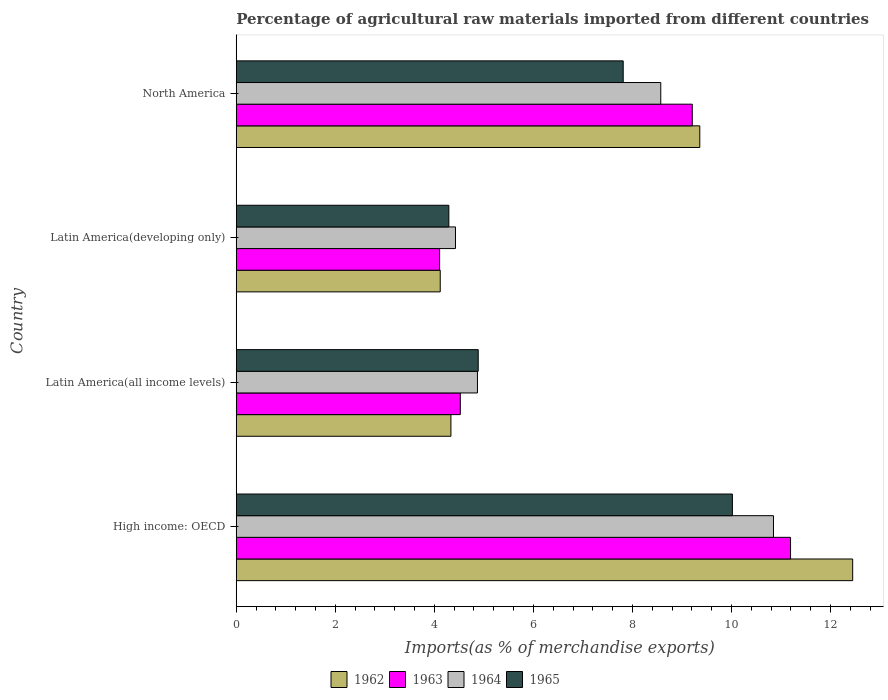How many groups of bars are there?
Your answer should be very brief. 4. Are the number of bars per tick equal to the number of legend labels?
Make the answer very short. Yes. Are the number of bars on each tick of the Y-axis equal?
Offer a terse response. Yes. How many bars are there on the 2nd tick from the top?
Provide a short and direct response. 4. How many bars are there on the 2nd tick from the bottom?
Your answer should be very brief. 4. What is the label of the 4th group of bars from the top?
Make the answer very short. High income: OECD. What is the percentage of imports to different countries in 1962 in High income: OECD?
Give a very brief answer. 12.45. Across all countries, what is the maximum percentage of imports to different countries in 1962?
Offer a very short reply. 12.45. Across all countries, what is the minimum percentage of imports to different countries in 1965?
Provide a succinct answer. 4.29. In which country was the percentage of imports to different countries in 1964 maximum?
Give a very brief answer. High income: OECD. In which country was the percentage of imports to different countries in 1963 minimum?
Offer a terse response. Latin America(developing only). What is the total percentage of imports to different countries in 1963 in the graph?
Keep it short and to the point. 29.03. What is the difference between the percentage of imports to different countries in 1962 in Latin America(developing only) and that in North America?
Your answer should be very brief. -5.24. What is the difference between the percentage of imports to different countries in 1964 in Latin America(all income levels) and the percentage of imports to different countries in 1965 in Latin America(developing only)?
Give a very brief answer. 0.58. What is the average percentage of imports to different countries in 1964 per country?
Your answer should be compact. 7.18. What is the difference between the percentage of imports to different countries in 1962 and percentage of imports to different countries in 1964 in Latin America(all income levels)?
Keep it short and to the point. -0.54. In how many countries, is the percentage of imports to different countries in 1964 greater than 7.6 %?
Offer a terse response. 2. What is the ratio of the percentage of imports to different countries in 1963 in Latin America(all income levels) to that in North America?
Give a very brief answer. 0.49. What is the difference between the highest and the second highest percentage of imports to different countries in 1964?
Your response must be concise. 2.28. What is the difference between the highest and the lowest percentage of imports to different countries in 1963?
Offer a very short reply. 7.09. In how many countries, is the percentage of imports to different countries in 1965 greater than the average percentage of imports to different countries in 1965 taken over all countries?
Make the answer very short. 2. Is the sum of the percentage of imports to different countries in 1963 in High income: OECD and Latin America(all income levels) greater than the maximum percentage of imports to different countries in 1964 across all countries?
Your response must be concise. Yes. Is it the case that in every country, the sum of the percentage of imports to different countries in 1963 and percentage of imports to different countries in 1965 is greater than the sum of percentage of imports to different countries in 1964 and percentage of imports to different countries in 1962?
Offer a terse response. No. What does the 1st bar from the top in High income: OECD represents?
Provide a succinct answer. 1965. What does the 3rd bar from the bottom in Latin America(all income levels) represents?
Your response must be concise. 1964. What is the difference between two consecutive major ticks on the X-axis?
Offer a very short reply. 2. Does the graph contain grids?
Offer a terse response. No. Where does the legend appear in the graph?
Offer a very short reply. Bottom center. How many legend labels are there?
Make the answer very short. 4. What is the title of the graph?
Your response must be concise. Percentage of agricultural raw materials imported from different countries. What is the label or title of the X-axis?
Give a very brief answer. Imports(as % of merchandise exports). What is the label or title of the Y-axis?
Provide a succinct answer. Country. What is the Imports(as % of merchandise exports) of 1962 in High income: OECD?
Ensure brevity in your answer.  12.45. What is the Imports(as % of merchandise exports) in 1963 in High income: OECD?
Your response must be concise. 11.19. What is the Imports(as % of merchandise exports) in 1964 in High income: OECD?
Your answer should be very brief. 10.85. What is the Imports(as % of merchandise exports) of 1965 in High income: OECD?
Your answer should be compact. 10.02. What is the Imports(as % of merchandise exports) of 1962 in Latin America(all income levels)?
Provide a succinct answer. 4.33. What is the Imports(as % of merchandise exports) of 1963 in Latin America(all income levels)?
Provide a short and direct response. 4.52. What is the Imports(as % of merchandise exports) of 1964 in Latin America(all income levels)?
Provide a short and direct response. 4.87. What is the Imports(as % of merchandise exports) of 1965 in Latin America(all income levels)?
Offer a very short reply. 4.89. What is the Imports(as % of merchandise exports) of 1962 in Latin America(developing only)?
Offer a very short reply. 4.12. What is the Imports(as % of merchandise exports) in 1963 in Latin America(developing only)?
Give a very brief answer. 4.11. What is the Imports(as % of merchandise exports) of 1964 in Latin America(developing only)?
Your answer should be very brief. 4.43. What is the Imports(as % of merchandise exports) of 1965 in Latin America(developing only)?
Keep it short and to the point. 4.29. What is the Imports(as % of merchandise exports) in 1962 in North America?
Make the answer very short. 9.36. What is the Imports(as % of merchandise exports) in 1963 in North America?
Offer a terse response. 9.21. What is the Imports(as % of merchandise exports) of 1964 in North America?
Offer a terse response. 8.57. What is the Imports(as % of merchandise exports) in 1965 in North America?
Your answer should be compact. 7.81. Across all countries, what is the maximum Imports(as % of merchandise exports) in 1962?
Make the answer very short. 12.45. Across all countries, what is the maximum Imports(as % of merchandise exports) in 1963?
Keep it short and to the point. 11.19. Across all countries, what is the maximum Imports(as % of merchandise exports) in 1964?
Ensure brevity in your answer.  10.85. Across all countries, what is the maximum Imports(as % of merchandise exports) of 1965?
Keep it short and to the point. 10.02. Across all countries, what is the minimum Imports(as % of merchandise exports) of 1962?
Give a very brief answer. 4.12. Across all countries, what is the minimum Imports(as % of merchandise exports) in 1963?
Ensure brevity in your answer.  4.11. Across all countries, what is the minimum Imports(as % of merchandise exports) in 1964?
Provide a succinct answer. 4.43. Across all countries, what is the minimum Imports(as % of merchandise exports) in 1965?
Make the answer very short. 4.29. What is the total Imports(as % of merchandise exports) in 1962 in the graph?
Ensure brevity in your answer.  30.26. What is the total Imports(as % of merchandise exports) of 1963 in the graph?
Provide a short and direct response. 29.03. What is the total Imports(as % of merchandise exports) of 1964 in the graph?
Your answer should be compact. 28.72. What is the total Imports(as % of merchandise exports) of 1965 in the graph?
Provide a short and direct response. 27.01. What is the difference between the Imports(as % of merchandise exports) of 1962 in High income: OECD and that in Latin America(all income levels)?
Offer a terse response. 8.11. What is the difference between the Imports(as % of merchandise exports) of 1963 in High income: OECD and that in Latin America(all income levels)?
Offer a terse response. 6.67. What is the difference between the Imports(as % of merchandise exports) in 1964 in High income: OECD and that in Latin America(all income levels)?
Provide a succinct answer. 5.98. What is the difference between the Imports(as % of merchandise exports) in 1965 in High income: OECD and that in Latin America(all income levels)?
Offer a terse response. 5.13. What is the difference between the Imports(as % of merchandise exports) of 1962 in High income: OECD and that in Latin America(developing only)?
Your response must be concise. 8.33. What is the difference between the Imports(as % of merchandise exports) in 1963 in High income: OECD and that in Latin America(developing only)?
Keep it short and to the point. 7.09. What is the difference between the Imports(as % of merchandise exports) of 1964 in High income: OECD and that in Latin America(developing only)?
Keep it short and to the point. 6.42. What is the difference between the Imports(as % of merchandise exports) of 1965 in High income: OECD and that in Latin America(developing only)?
Provide a short and direct response. 5.73. What is the difference between the Imports(as % of merchandise exports) in 1962 in High income: OECD and that in North America?
Give a very brief answer. 3.09. What is the difference between the Imports(as % of merchandise exports) in 1963 in High income: OECD and that in North America?
Provide a succinct answer. 1.98. What is the difference between the Imports(as % of merchandise exports) of 1964 in High income: OECD and that in North America?
Make the answer very short. 2.28. What is the difference between the Imports(as % of merchandise exports) of 1965 in High income: OECD and that in North America?
Make the answer very short. 2.21. What is the difference between the Imports(as % of merchandise exports) in 1962 in Latin America(all income levels) and that in Latin America(developing only)?
Your response must be concise. 0.22. What is the difference between the Imports(as % of merchandise exports) of 1963 in Latin America(all income levels) and that in Latin America(developing only)?
Your answer should be compact. 0.42. What is the difference between the Imports(as % of merchandise exports) of 1964 in Latin America(all income levels) and that in Latin America(developing only)?
Give a very brief answer. 0.44. What is the difference between the Imports(as % of merchandise exports) of 1965 in Latin America(all income levels) and that in Latin America(developing only)?
Make the answer very short. 0.59. What is the difference between the Imports(as % of merchandise exports) of 1962 in Latin America(all income levels) and that in North America?
Provide a succinct answer. -5.03. What is the difference between the Imports(as % of merchandise exports) of 1963 in Latin America(all income levels) and that in North America?
Your response must be concise. -4.68. What is the difference between the Imports(as % of merchandise exports) in 1964 in Latin America(all income levels) and that in North America?
Keep it short and to the point. -3.7. What is the difference between the Imports(as % of merchandise exports) in 1965 in Latin America(all income levels) and that in North America?
Your answer should be very brief. -2.93. What is the difference between the Imports(as % of merchandise exports) in 1962 in Latin America(developing only) and that in North America?
Give a very brief answer. -5.24. What is the difference between the Imports(as % of merchandise exports) of 1963 in Latin America(developing only) and that in North America?
Offer a terse response. -5.1. What is the difference between the Imports(as % of merchandise exports) in 1964 in Latin America(developing only) and that in North America?
Provide a short and direct response. -4.15. What is the difference between the Imports(as % of merchandise exports) in 1965 in Latin America(developing only) and that in North America?
Provide a succinct answer. -3.52. What is the difference between the Imports(as % of merchandise exports) in 1962 in High income: OECD and the Imports(as % of merchandise exports) in 1963 in Latin America(all income levels)?
Provide a short and direct response. 7.92. What is the difference between the Imports(as % of merchandise exports) of 1962 in High income: OECD and the Imports(as % of merchandise exports) of 1964 in Latin America(all income levels)?
Your answer should be very brief. 7.58. What is the difference between the Imports(as % of merchandise exports) in 1962 in High income: OECD and the Imports(as % of merchandise exports) in 1965 in Latin America(all income levels)?
Your response must be concise. 7.56. What is the difference between the Imports(as % of merchandise exports) in 1963 in High income: OECD and the Imports(as % of merchandise exports) in 1964 in Latin America(all income levels)?
Your answer should be compact. 6.32. What is the difference between the Imports(as % of merchandise exports) in 1963 in High income: OECD and the Imports(as % of merchandise exports) in 1965 in Latin America(all income levels)?
Your answer should be compact. 6.31. What is the difference between the Imports(as % of merchandise exports) in 1964 in High income: OECD and the Imports(as % of merchandise exports) in 1965 in Latin America(all income levels)?
Your response must be concise. 5.96. What is the difference between the Imports(as % of merchandise exports) of 1962 in High income: OECD and the Imports(as % of merchandise exports) of 1963 in Latin America(developing only)?
Keep it short and to the point. 8.34. What is the difference between the Imports(as % of merchandise exports) of 1962 in High income: OECD and the Imports(as % of merchandise exports) of 1964 in Latin America(developing only)?
Keep it short and to the point. 8.02. What is the difference between the Imports(as % of merchandise exports) of 1962 in High income: OECD and the Imports(as % of merchandise exports) of 1965 in Latin America(developing only)?
Ensure brevity in your answer.  8.15. What is the difference between the Imports(as % of merchandise exports) in 1963 in High income: OECD and the Imports(as % of merchandise exports) in 1964 in Latin America(developing only)?
Make the answer very short. 6.77. What is the difference between the Imports(as % of merchandise exports) in 1963 in High income: OECD and the Imports(as % of merchandise exports) in 1965 in Latin America(developing only)?
Offer a terse response. 6.9. What is the difference between the Imports(as % of merchandise exports) of 1964 in High income: OECD and the Imports(as % of merchandise exports) of 1965 in Latin America(developing only)?
Your answer should be very brief. 6.55. What is the difference between the Imports(as % of merchandise exports) of 1962 in High income: OECD and the Imports(as % of merchandise exports) of 1963 in North America?
Your answer should be very brief. 3.24. What is the difference between the Imports(as % of merchandise exports) in 1962 in High income: OECD and the Imports(as % of merchandise exports) in 1964 in North America?
Keep it short and to the point. 3.87. What is the difference between the Imports(as % of merchandise exports) in 1962 in High income: OECD and the Imports(as % of merchandise exports) in 1965 in North America?
Your answer should be compact. 4.63. What is the difference between the Imports(as % of merchandise exports) of 1963 in High income: OECD and the Imports(as % of merchandise exports) of 1964 in North America?
Your response must be concise. 2.62. What is the difference between the Imports(as % of merchandise exports) in 1963 in High income: OECD and the Imports(as % of merchandise exports) in 1965 in North America?
Your response must be concise. 3.38. What is the difference between the Imports(as % of merchandise exports) of 1964 in High income: OECD and the Imports(as % of merchandise exports) of 1965 in North America?
Offer a very short reply. 3.03. What is the difference between the Imports(as % of merchandise exports) of 1962 in Latin America(all income levels) and the Imports(as % of merchandise exports) of 1963 in Latin America(developing only)?
Provide a succinct answer. 0.23. What is the difference between the Imports(as % of merchandise exports) in 1962 in Latin America(all income levels) and the Imports(as % of merchandise exports) in 1964 in Latin America(developing only)?
Offer a terse response. -0.09. What is the difference between the Imports(as % of merchandise exports) in 1962 in Latin America(all income levels) and the Imports(as % of merchandise exports) in 1965 in Latin America(developing only)?
Your answer should be compact. 0.04. What is the difference between the Imports(as % of merchandise exports) of 1963 in Latin America(all income levels) and the Imports(as % of merchandise exports) of 1964 in Latin America(developing only)?
Your response must be concise. 0.1. What is the difference between the Imports(as % of merchandise exports) in 1963 in Latin America(all income levels) and the Imports(as % of merchandise exports) in 1965 in Latin America(developing only)?
Your answer should be very brief. 0.23. What is the difference between the Imports(as % of merchandise exports) in 1964 in Latin America(all income levels) and the Imports(as % of merchandise exports) in 1965 in Latin America(developing only)?
Your answer should be very brief. 0.58. What is the difference between the Imports(as % of merchandise exports) in 1962 in Latin America(all income levels) and the Imports(as % of merchandise exports) in 1963 in North America?
Keep it short and to the point. -4.87. What is the difference between the Imports(as % of merchandise exports) of 1962 in Latin America(all income levels) and the Imports(as % of merchandise exports) of 1964 in North America?
Provide a short and direct response. -4.24. What is the difference between the Imports(as % of merchandise exports) in 1962 in Latin America(all income levels) and the Imports(as % of merchandise exports) in 1965 in North America?
Offer a very short reply. -3.48. What is the difference between the Imports(as % of merchandise exports) in 1963 in Latin America(all income levels) and the Imports(as % of merchandise exports) in 1964 in North America?
Offer a terse response. -4.05. What is the difference between the Imports(as % of merchandise exports) of 1963 in Latin America(all income levels) and the Imports(as % of merchandise exports) of 1965 in North America?
Your response must be concise. -3.29. What is the difference between the Imports(as % of merchandise exports) in 1964 in Latin America(all income levels) and the Imports(as % of merchandise exports) in 1965 in North America?
Give a very brief answer. -2.94. What is the difference between the Imports(as % of merchandise exports) of 1962 in Latin America(developing only) and the Imports(as % of merchandise exports) of 1963 in North America?
Your answer should be very brief. -5.09. What is the difference between the Imports(as % of merchandise exports) of 1962 in Latin America(developing only) and the Imports(as % of merchandise exports) of 1964 in North America?
Keep it short and to the point. -4.45. What is the difference between the Imports(as % of merchandise exports) in 1962 in Latin America(developing only) and the Imports(as % of merchandise exports) in 1965 in North America?
Your answer should be compact. -3.69. What is the difference between the Imports(as % of merchandise exports) in 1963 in Latin America(developing only) and the Imports(as % of merchandise exports) in 1964 in North America?
Offer a terse response. -4.47. What is the difference between the Imports(as % of merchandise exports) in 1963 in Latin America(developing only) and the Imports(as % of merchandise exports) in 1965 in North America?
Provide a succinct answer. -3.71. What is the difference between the Imports(as % of merchandise exports) in 1964 in Latin America(developing only) and the Imports(as % of merchandise exports) in 1965 in North America?
Offer a very short reply. -3.39. What is the average Imports(as % of merchandise exports) in 1962 per country?
Your response must be concise. 7.56. What is the average Imports(as % of merchandise exports) of 1963 per country?
Your answer should be compact. 7.26. What is the average Imports(as % of merchandise exports) of 1964 per country?
Your answer should be compact. 7.18. What is the average Imports(as % of merchandise exports) in 1965 per country?
Make the answer very short. 6.75. What is the difference between the Imports(as % of merchandise exports) in 1962 and Imports(as % of merchandise exports) in 1963 in High income: OECD?
Offer a very short reply. 1.25. What is the difference between the Imports(as % of merchandise exports) of 1962 and Imports(as % of merchandise exports) of 1964 in High income: OECD?
Make the answer very short. 1.6. What is the difference between the Imports(as % of merchandise exports) in 1962 and Imports(as % of merchandise exports) in 1965 in High income: OECD?
Ensure brevity in your answer.  2.43. What is the difference between the Imports(as % of merchandise exports) in 1963 and Imports(as % of merchandise exports) in 1964 in High income: OECD?
Offer a terse response. 0.34. What is the difference between the Imports(as % of merchandise exports) in 1963 and Imports(as % of merchandise exports) in 1965 in High income: OECD?
Offer a terse response. 1.17. What is the difference between the Imports(as % of merchandise exports) of 1964 and Imports(as % of merchandise exports) of 1965 in High income: OECD?
Give a very brief answer. 0.83. What is the difference between the Imports(as % of merchandise exports) of 1962 and Imports(as % of merchandise exports) of 1963 in Latin America(all income levels)?
Your response must be concise. -0.19. What is the difference between the Imports(as % of merchandise exports) in 1962 and Imports(as % of merchandise exports) in 1964 in Latin America(all income levels)?
Give a very brief answer. -0.54. What is the difference between the Imports(as % of merchandise exports) in 1962 and Imports(as % of merchandise exports) in 1965 in Latin America(all income levels)?
Provide a short and direct response. -0.55. What is the difference between the Imports(as % of merchandise exports) of 1963 and Imports(as % of merchandise exports) of 1964 in Latin America(all income levels)?
Provide a short and direct response. -0.35. What is the difference between the Imports(as % of merchandise exports) in 1963 and Imports(as % of merchandise exports) in 1965 in Latin America(all income levels)?
Your response must be concise. -0.36. What is the difference between the Imports(as % of merchandise exports) in 1964 and Imports(as % of merchandise exports) in 1965 in Latin America(all income levels)?
Offer a very short reply. -0.02. What is the difference between the Imports(as % of merchandise exports) of 1962 and Imports(as % of merchandise exports) of 1963 in Latin America(developing only)?
Provide a succinct answer. 0.01. What is the difference between the Imports(as % of merchandise exports) in 1962 and Imports(as % of merchandise exports) in 1964 in Latin America(developing only)?
Ensure brevity in your answer.  -0.31. What is the difference between the Imports(as % of merchandise exports) in 1962 and Imports(as % of merchandise exports) in 1965 in Latin America(developing only)?
Provide a short and direct response. -0.17. What is the difference between the Imports(as % of merchandise exports) of 1963 and Imports(as % of merchandise exports) of 1964 in Latin America(developing only)?
Provide a short and direct response. -0.32. What is the difference between the Imports(as % of merchandise exports) in 1963 and Imports(as % of merchandise exports) in 1965 in Latin America(developing only)?
Offer a very short reply. -0.19. What is the difference between the Imports(as % of merchandise exports) in 1964 and Imports(as % of merchandise exports) in 1965 in Latin America(developing only)?
Give a very brief answer. 0.13. What is the difference between the Imports(as % of merchandise exports) of 1962 and Imports(as % of merchandise exports) of 1963 in North America?
Offer a very short reply. 0.15. What is the difference between the Imports(as % of merchandise exports) in 1962 and Imports(as % of merchandise exports) in 1964 in North America?
Ensure brevity in your answer.  0.79. What is the difference between the Imports(as % of merchandise exports) in 1962 and Imports(as % of merchandise exports) in 1965 in North America?
Your answer should be compact. 1.55. What is the difference between the Imports(as % of merchandise exports) in 1963 and Imports(as % of merchandise exports) in 1964 in North America?
Provide a short and direct response. 0.64. What is the difference between the Imports(as % of merchandise exports) of 1963 and Imports(as % of merchandise exports) of 1965 in North America?
Your response must be concise. 1.39. What is the difference between the Imports(as % of merchandise exports) of 1964 and Imports(as % of merchandise exports) of 1965 in North America?
Give a very brief answer. 0.76. What is the ratio of the Imports(as % of merchandise exports) of 1962 in High income: OECD to that in Latin America(all income levels)?
Your answer should be very brief. 2.87. What is the ratio of the Imports(as % of merchandise exports) of 1963 in High income: OECD to that in Latin America(all income levels)?
Ensure brevity in your answer.  2.47. What is the ratio of the Imports(as % of merchandise exports) of 1964 in High income: OECD to that in Latin America(all income levels)?
Provide a short and direct response. 2.23. What is the ratio of the Imports(as % of merchandise exports) of 1965 in High income: OECD to that in Latin America(all income levels)?
Offer a terse response. 2.05. What is the ratio of the Imports(as % of merchandise exports) of 1962 in High income: OECD to that in Latin America(developing only)?
Provide a succinct answer. 3.02. What is the ratio of the Imports(as % of merchandise exports) of 1963 in High income: OECD to that in Latin America(developing only)?
Make the answer very short. 2.73. What is the ratio of the Imports(as % of merchandise exports) of 1964 in High income: OECD to that in Latin America(developing only)?
Provide a succinct answer. 2.45. What is the ratio of the Imports(as % of merchandise exports) in 1965 in High income: OECD to that in Latin America(developing only)?
Your answer should be very brief. 2.33. What is the ratio of the Imports(as % of merchandise exports) of 1962 in High income: OECD to that in North America?
Make the answer very short. 1.33. What is the ratio of the Imports(as % of merchandise exports) in 1963 in High income: OECD to that in North America?
Offer a terse response. 1.22. What is the ratio of the Imports(as % of merchandise exports) in 1964 in High income: OECD to that in North America?
Keep it short and to the point. 1.27. What is the ratio of the Imports(as % of merchandise exports) of 1965 in High income: OECD to that in North America?
Your response must be concise. 1.28. What is the ratio of the Imports(as % of merchandise exports) of 1962 in Latin America(all income levels) to that in Latin America(developing only)?
Your response must be concise. 1.05. What is the ratio of the Imports(as % of merchandise exports) in 1963 in Latin America(all income levels) to that in Latin America(developing only)?
Ensure brevity in your answer.  1.1. What is the ratio of the Imports(as % of merchandise exports) in 1964 in Latin America(all income levels) to that in Latin America(developing only)?
Provide a short and direct response. 1.1. What is the ratio of the Imports(as % of merchandise exports) in 1965 in Latin America(all income levels) to that in Latin America(developing only)?
Keep it short and to the point. 1.14. What is the ratio of the Imports(as % of merchandise exports) of 1962 in Latin America(all income levels) to that in North America?
Offer a terse response. 0.46. What is the ratio of the Imports(as % of merchandise exports) in 1963 in Latin America(all income levels) to that in North America?
Your response must be concise. 0.49. What is the ratio of the Imports(as % of merchandise exports) in 1964 in Latin America(all income levels) to that in North America?
Offer a very short reply. 0.57. What is the ratio of the Imports(as % of merchandise exports) of 1965 in Latin America(all income levels) to that in North America?
Keep it short and to the point. 0.63. What is the ratio of the Imports(as % of merchandise exports) in 1962 in Latin America(developing only) to that in North America?
Provide a short and direct response. 0.44. What is the ratio of the Imports(as % of merchandise exports) of 1963 in Latin America(developing only) to that in North America?
Provide a succinct answer. 0.45. What is the ratio of the Imports(as % of merchandise exports) of 1964 in Latin America(developing only) to that in North America?
Give a very brief answer. 0.52. What is the ratio of the Imports(as % of merchandise exports) in 1965 in Latin America(developing only) to that in North America?
Offer a terse response. 0.55. What is the difference between the highest and the second highest Imports(as % of merchandise exports) in 1962?
Give a very brief answer. 3.09. What is the difference between the highest and the second highest Imports(as % of merchandise exports) of 1963?
Your answer should be compact. 1.98. What is the difference between the highest and the second highest Imports(as % of merchandise exports) in 1964?
Your answer should be very brief. 2.28. What is the difference between the highest and the second highest Imports(as % of merchandise exports) in 1965?
Offer a very short reply. 2.21. What is the difference between the highest and the lowest Imports(as % of merchandise exports) in 1962?
Provide a short and direct response. 8.33. What is the difference between the highest and the lowest Imports(as % of merchandise exports) in 1963?
Make the answer very short. 7.09. What is the difference between the highest and the lowest Imports(as % of merchandise exports) in 1964?
Provide a short and direct response. 6.42. What is the difference between the highest and the lowest Imports(as % of merchandise exports) in 1965?
Ensure brevity in your answer.  5.73. 